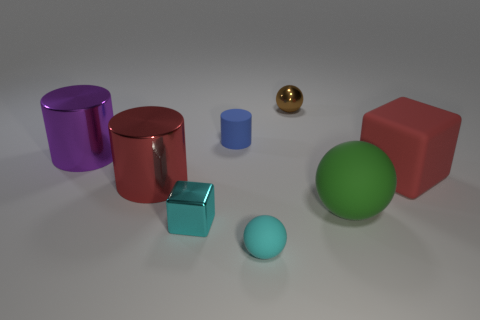Can you tell me the colors of the cylinders in the image? Certainly! In the image, there are two cylinders, one is blue with a matte finish, and the other is purple, also with a matte finish. 